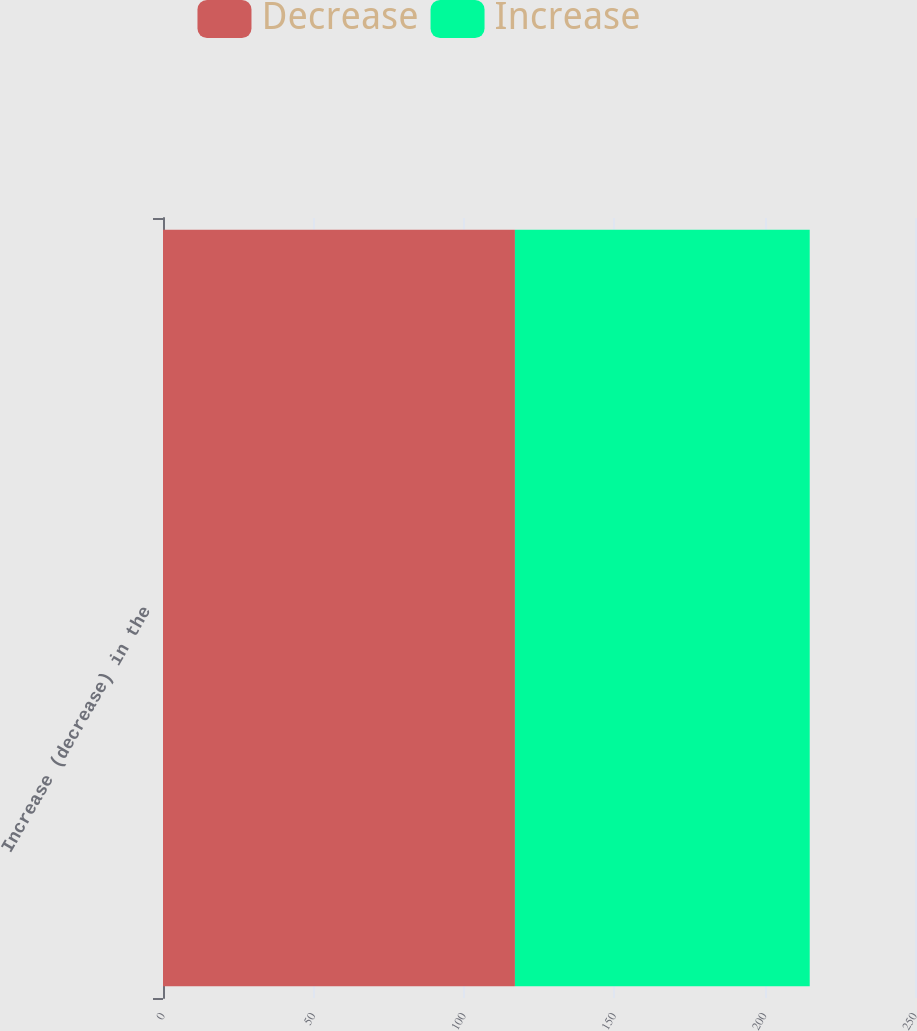Convert chart to OTSL. <chart><loc_0><loc_0><loc_500><loc_500><stacked_bar_chart><ecel><fcel>Increase (decrease) in the<nl><fcel>Decrease<fcel>117<nl><fcel>Increase<fcel>98<nl></chart> 